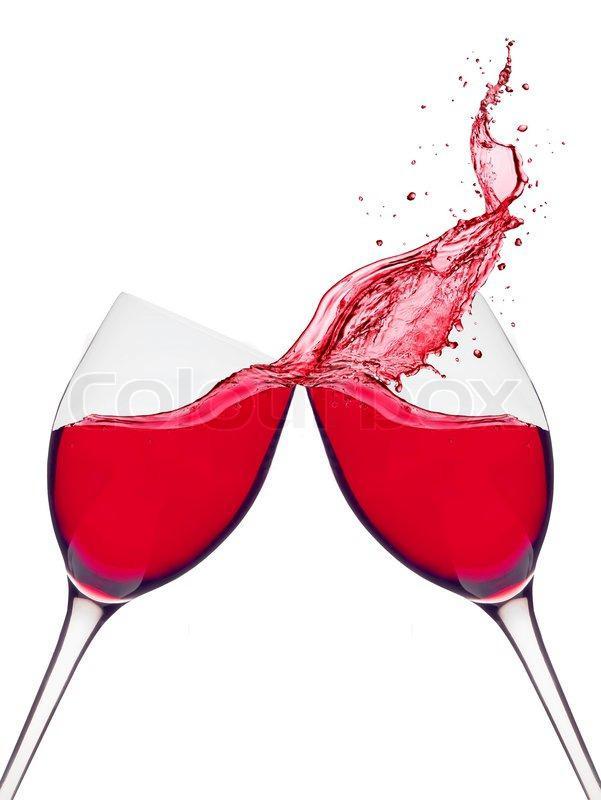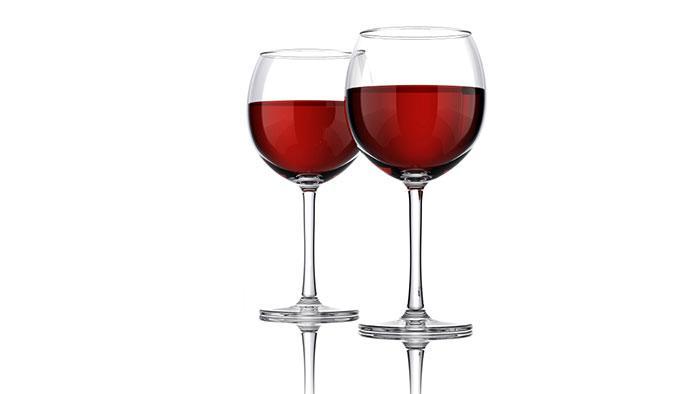The first image is the image on the left, the second image is the image on the right. Analyze the images presented: Is the assertion "One image shows two glasses of red wine clinking together with wine spilling out and the other image shows only two still glasses of red wine side by side" valid? Answer yes or no. Yes. The first image is the image on the left, the second image is the image on the right. Assess this claim about the two images: "Each image contains two wine glasses and no bottles, and left image shows red wine splashing from glasses clinked together.". Correct or not? Answer yes or no. Yes. 